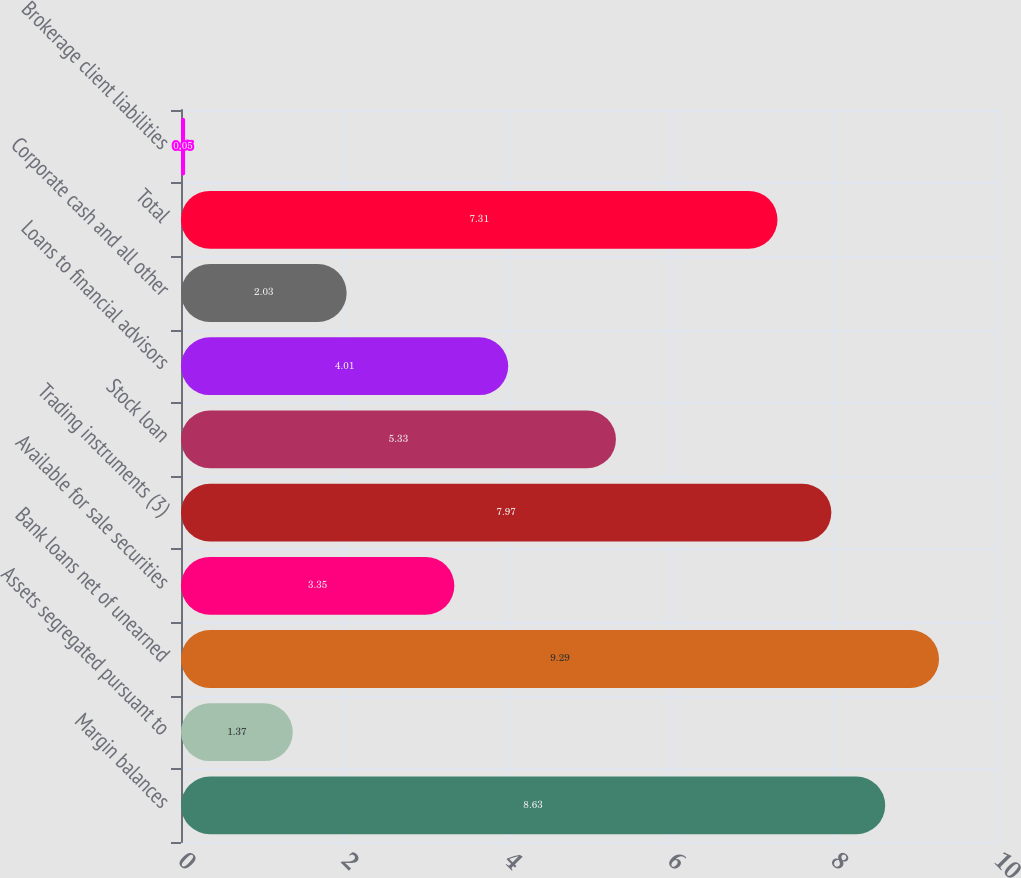<chart> <loc_0><loc_0><loc_500><loc_500><bar_chart><fcel>Margin balances<fcel>Assets segregated pursuant to<fcel>Bank loans net of unearned<fcel>Available for sale securities<fcel>Trading instruments (3)<fcel>Stock loan<fcel>Loans to financial advisors<fcel>Corporate cash and all other<fcel>Total<fcel>Brokerage client liabilities<nl><fcel>8.63<fcel>1.37<fcel>9.29<fcel>3.35<fcel>7.97<fcel>5.33<fcel>4.01<fcel>2.03<fcel>7.31<fcel>0.05<nl></chart> 